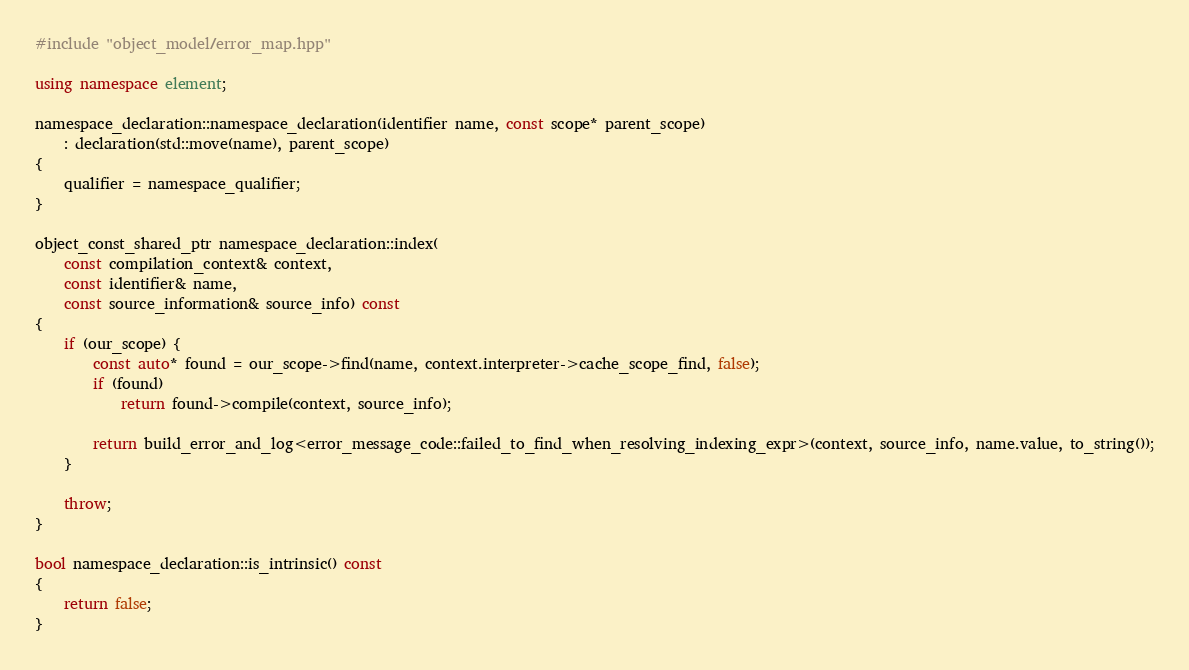<code> <loc_0><loc_0><loc_500><loc_500><_C++_>#include "object_model/error_map.hpp"

using namespace element;

namespace_declaration::namespace_declaration(identifier name, const scope* parent_scope)
    : declaration(std::move(name), parent_scope)
{
    qualifier = namespace_qualifier;
}

object_const_shared_ptr namespace_declaration::index(
    const compilation_context& context,
    const identifier& name,
    const source_information& source_info) const
{
    if (our_scope) {
        const auto* found = our_scope->find(name, context.interpreter->cache_scope_find, false);
        if (found)
            return found->compile(context, source_info);

        return build_error_and_log<error_message_code::failed_to_find_when_resolving_indexing_expr>(context, source_info, name.value, to_string());
    }

    throw;
}

bool namespace_declaration::is_intrinsic() const
{
    return false;
}</code> 